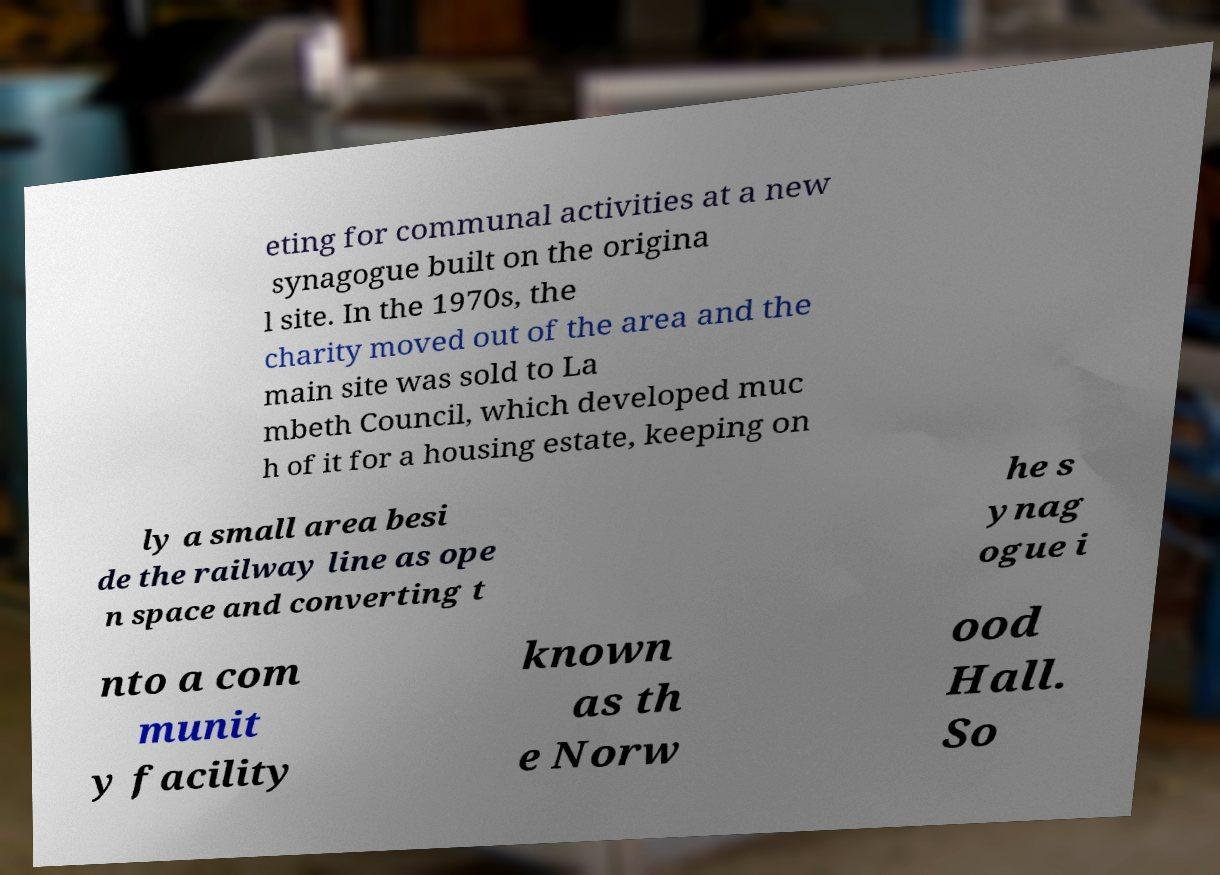What messages or text are displayed in this image? I need them in a readable, typed format. eting for communal activities at a new synagogue built on the origina l site. In the 1970s, the charity moved out of the area and the main site was sold to La mbeth Council, which developed muc h of it for a housing estate, keeping on ly a small area besi de the railway line as ope n space and converting t he s ynag ogue i nto a com munit y facility known as th e Norw ood Hall. So 